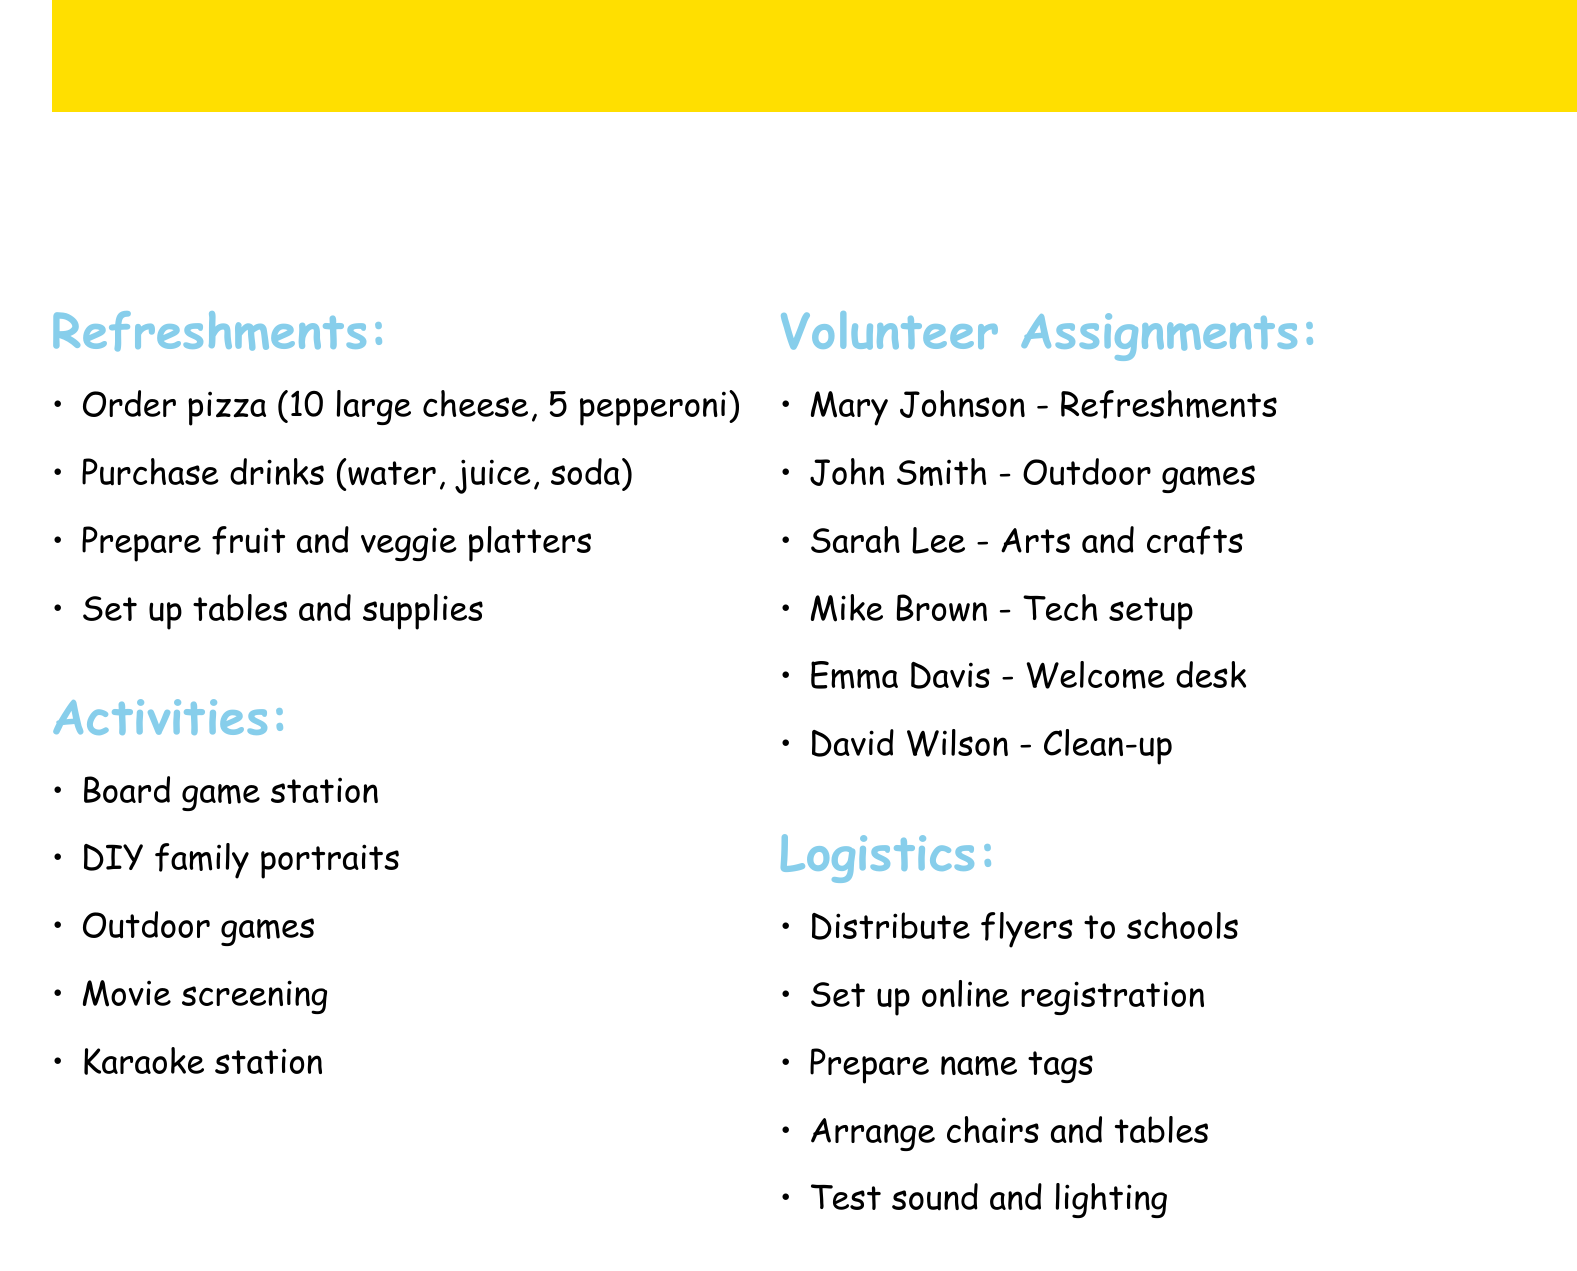What is the date of the event? The date of the Family Fun Night event is explicitly mentioned in the document.
Answer: Friday, May 12, 2023 How many pizzas need to be ordered? The document states the exact number of pizzas required for refreshments.
Answer: 15 Who is the volunteer assigned to manage refreshments? The document lists the names and assignments of the volunteers.
Answer: Mary Johnson What activity involves a projector? The document describes the setup of activities that includes the use of specific equipment.
Answer: Movie screening List one type of drink to be purchased. The document specifies the variety of drinks that will be purchased for refreshments.
Answer: Juice boxes How many outdoor games are mentioned? The activities section outlines the total number of outdoor games included in the event plan.
Answer: Three What is one logistical task to be completed? The logistics section details tasks that need to be handled before the event.
Answer: Arrange chairs and tables Which volunteer is responsible for technology setup? The volunteer assignments indicate specific responsibilities, including technology setup.
Answer: Mike Brown 